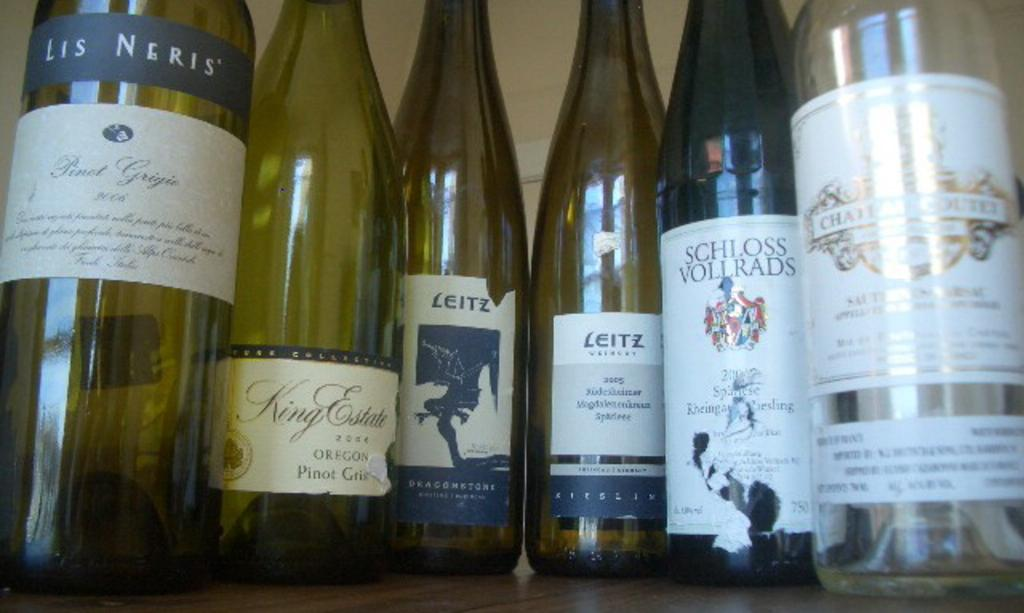<image>
Present a compact description of the photo's key features. A Lis Negris' wine is on the left of 5 other bottles of different wines. 